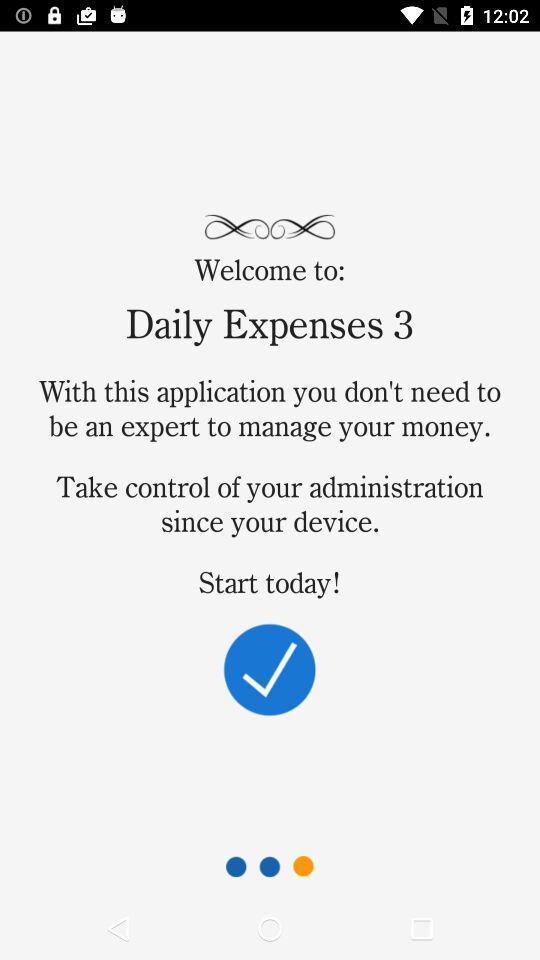Give me a narrative description of this picture. Welcome page. 